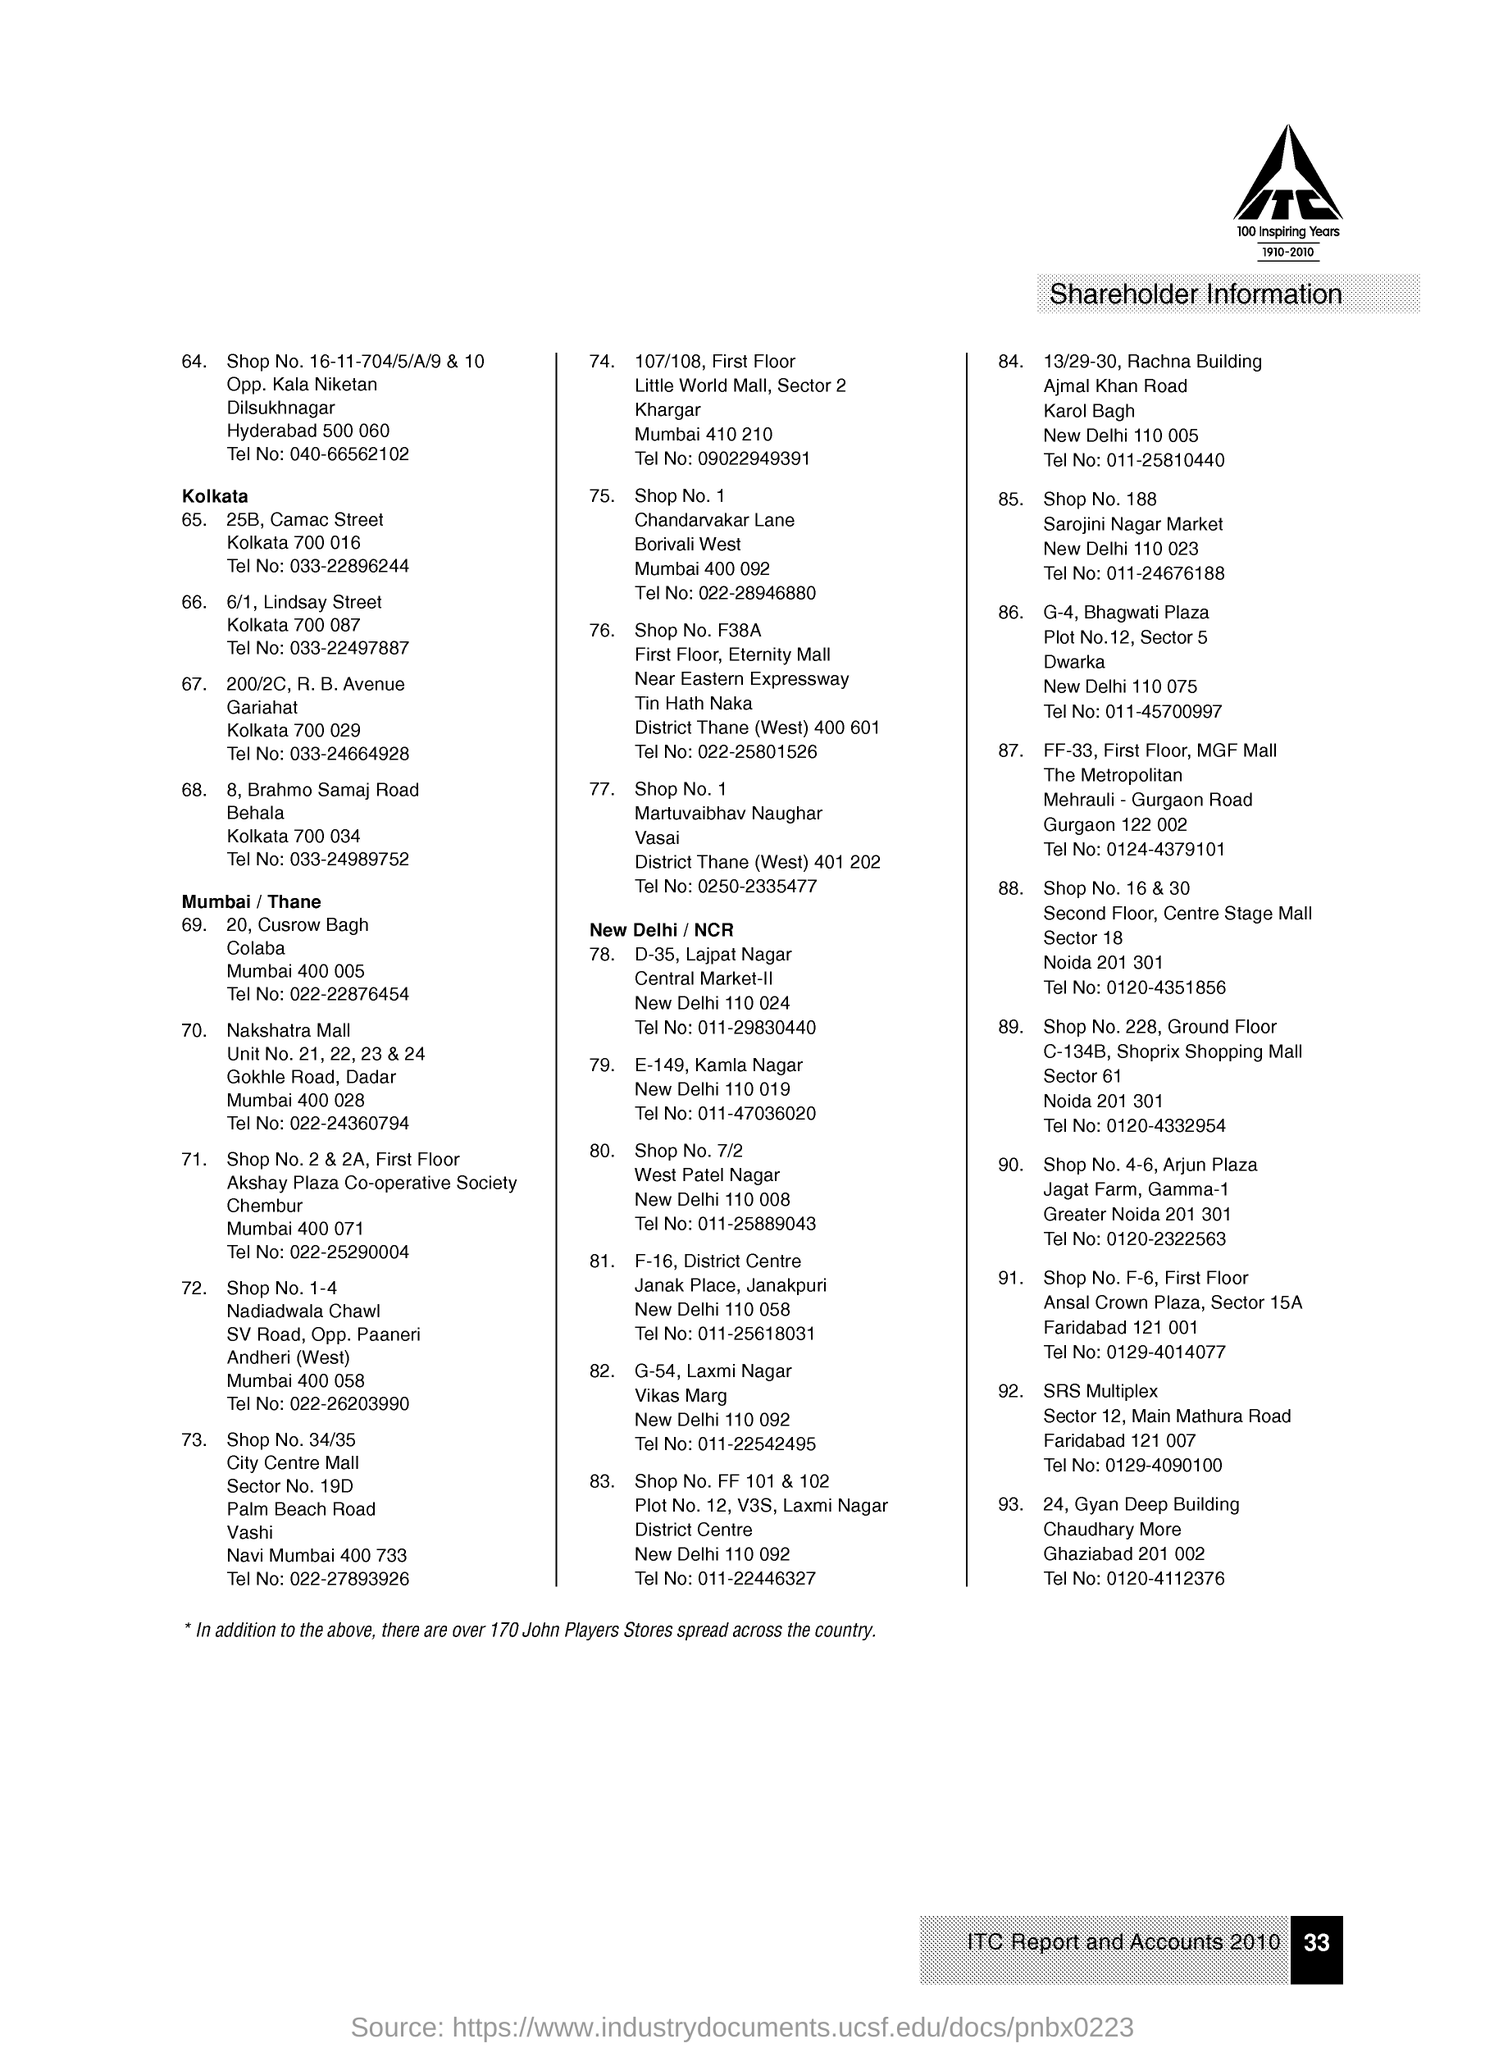Outline some significant characteristics in this image. The page contains information about shareholder information. The maximum number of shareholder information is given from the city of New Delhi. The company logo includes a time frame of 1910 to 2010, which is mentioned under the logo. The text located in the logo, found in the right top corner of the page, is ITC. The last address was assigned a serial number of 93... 